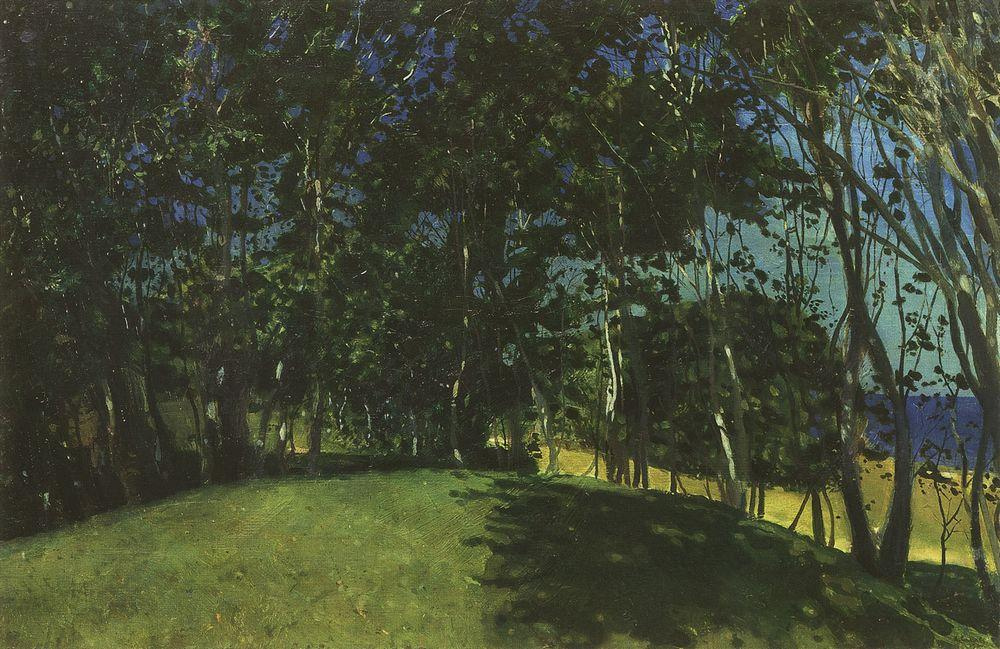Can you describe the types of trees shown in the painting? The painting primarily features mature deciduous trees, likely oaks or elms, with their intricate branch patterns and lush, dense foliage. The artist has used dark greens to capture the density of the leaves, while lighter and warmer tones might suggest the presence of a few younger or smaller trees, which add a vibrant contrast to the scene. 